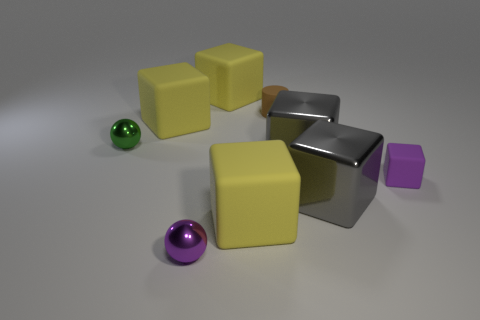Does the brown object have the same size as the purple matte thing that is in front of the small brown matte cylinder?
Ensure brevity in your answer.  Yes. Is there another small cylinder that has the same color as the cylinder?
Make the answer very short. No. What is the size of the purple block that is the same material as the tiny brown thing?
Your answer should be very brief. Small. Do the green thing and the cylinder have the same material?
Provide a succinct answer. No. There is a large rubber cube in front of the yellow rubber cube that is to the left of the yellow matte block that is behind the small brown rubber cylinder; what color is it?
Your response must be concise. Yellow. What shape is the brown object?
Provide a short and direct response. Cylinder. Do the rubber cylinder and the small object right of the brown thing have the same color?
Provide a succinct answer. No. Is the number of small brown objects on the left side of the purple metallic thing the same as the number of tiny blue rubber objects?
Keep it short and to the point. Yes. How many shiny balls are the same size as the purple metallic object?
Ensure brevity in your answer.  1. There is a metal thing that is the same color as the tiny matte block; what shape is it?
Offer a terse response. Sphere. 